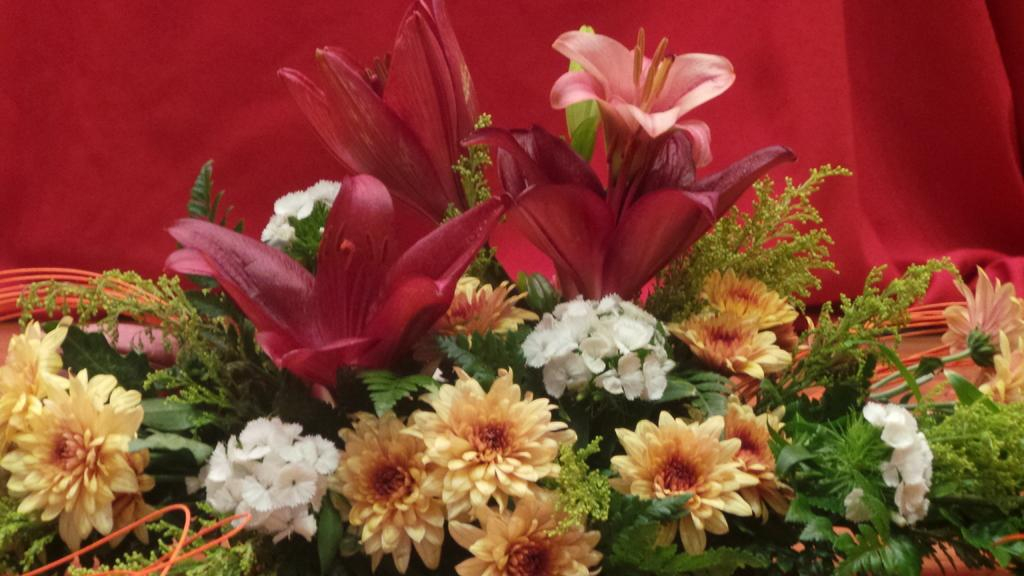What is the main subject of the image? The main subject of the image is colorful flowers. Where are the flowers located in the image? The flowers are in the center of the image. What can be seen in the background of the image? There is a red color curtain in the background area of the image. What type of leaf is visible in the image? There is no leaf visible in the image; it features colorful flowers and a red color curtain. 